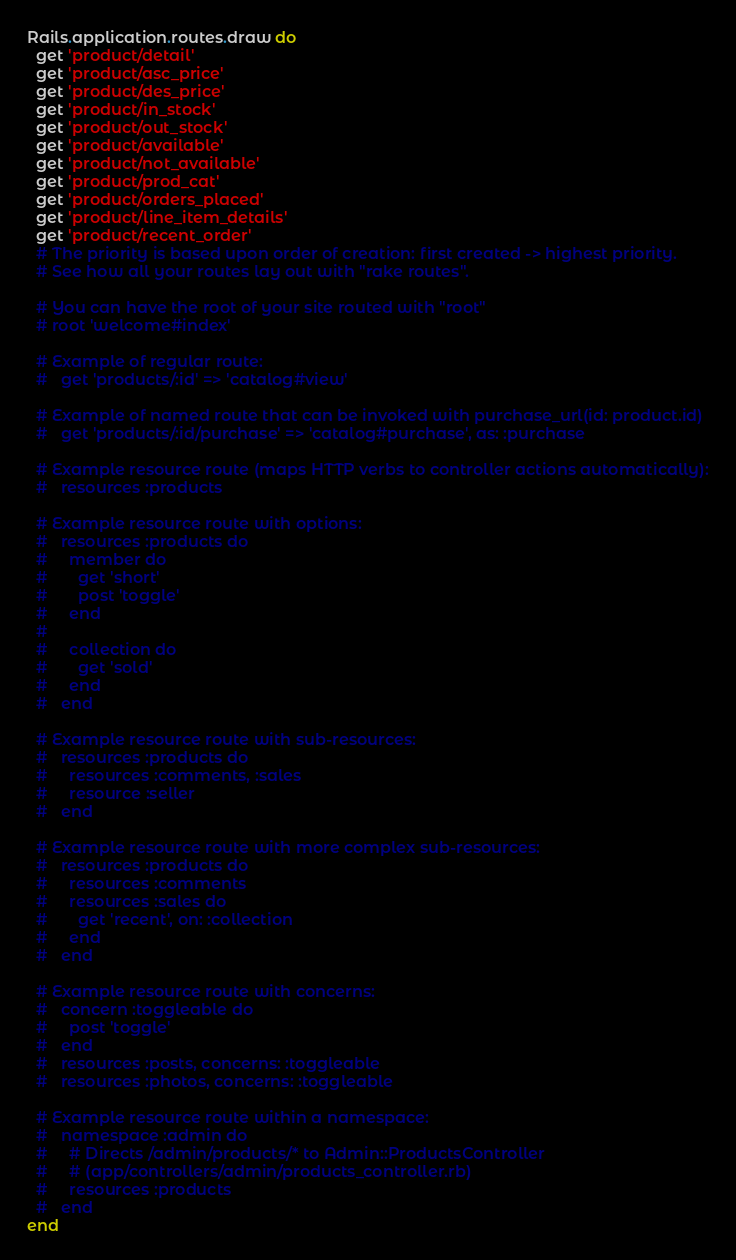Convert code to text. <code><loc_0><loc_0><loc_500><loc_500><_Ruby_>Rails.application.routes.draw do
  get 'product/detail'
  get 'product/asc_price'
  get 'product/des_price'
  get 'product/in_stock'
  get 'product/out_stock'
  get 'product/available'
  get 'product/not_available'
  get 'product/prod_cat'
  get 'product/orders_placed'
  get 'product/line_item_details'
  get 'product/recent_order'
  # The priority is based upon order of creation: first created -> highest priority.
  # See how all your routes lay out with "rake routes".

  # You can have the root of your site routed with "root"
  # root 'welcome#index'

  # Example of regular route:
  #   get 'products/:id' => 'catalog#view'

  # Example of named route that can be invoked with purchase_url(id: product.id)
  #   get 'products/:id/purchase' => 'catalog#purchase', as: :purchase

  # Example resource route (maps HTTP verbs to controller actions automatically):
  #   resources :products

  # Example resource route with options:
  #   resources :products do
  #     member do
  #       get 'short'
  #       post 'toggle'
  #     end
  #
  #     collection do
  #       get 'sold'
  #     end
  #   end

  # Example resource route with sub-resources:
  #   resources :products do
  #     resources :comments, :sales
  #     resource :seller
  #   end

  # Example resource route with more complex sub-resources:
  #   resources :products do
  #     resources :comments
  #     resources :sales do
  #       get 'recent', on: :collection
  #     end
  #   end

  # Example resource route with concerns:
  #   concern :toggleable do
  #     post 'toggle'
  #   end
  #   resources :posts, concerns: :toggleable
  #   resources :photos, concerns: :toggleable

  # Example resource route within a namespace:
  #   namespace :admin do
  #     # Directs /admin/products/* to Admin::ProductsController
  #     # (app/controllers/admin/products_controller.rb)
  #     resources :products
  #   end
end
</code> 